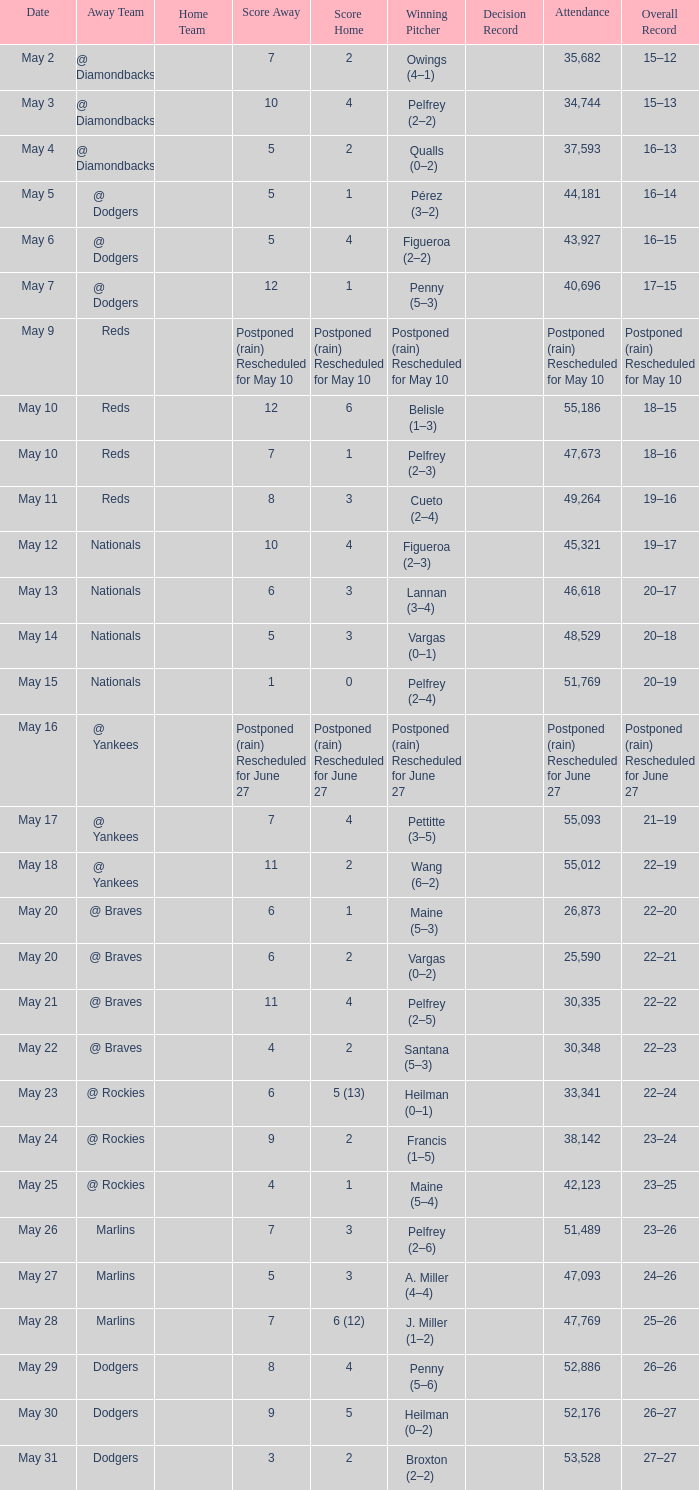Record of 22–20 involved what score? 6–1. 